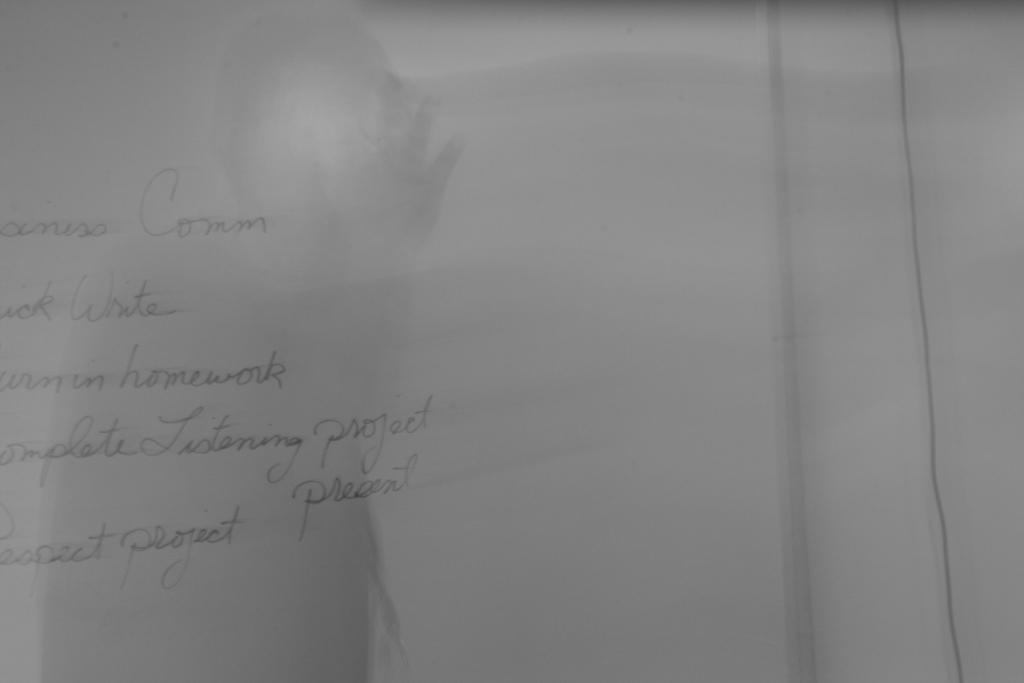What is the main object in the image? The main object in the image is a paper. What can be seen on the paper? There is writing on the paper. What type of skirt is visible in the image? There is no skirt present in the image; it only features a paper with writing on it. What joke can be read on the sign in the image? There is no sign or joke present in the image; it only features a paper with writing on it. 